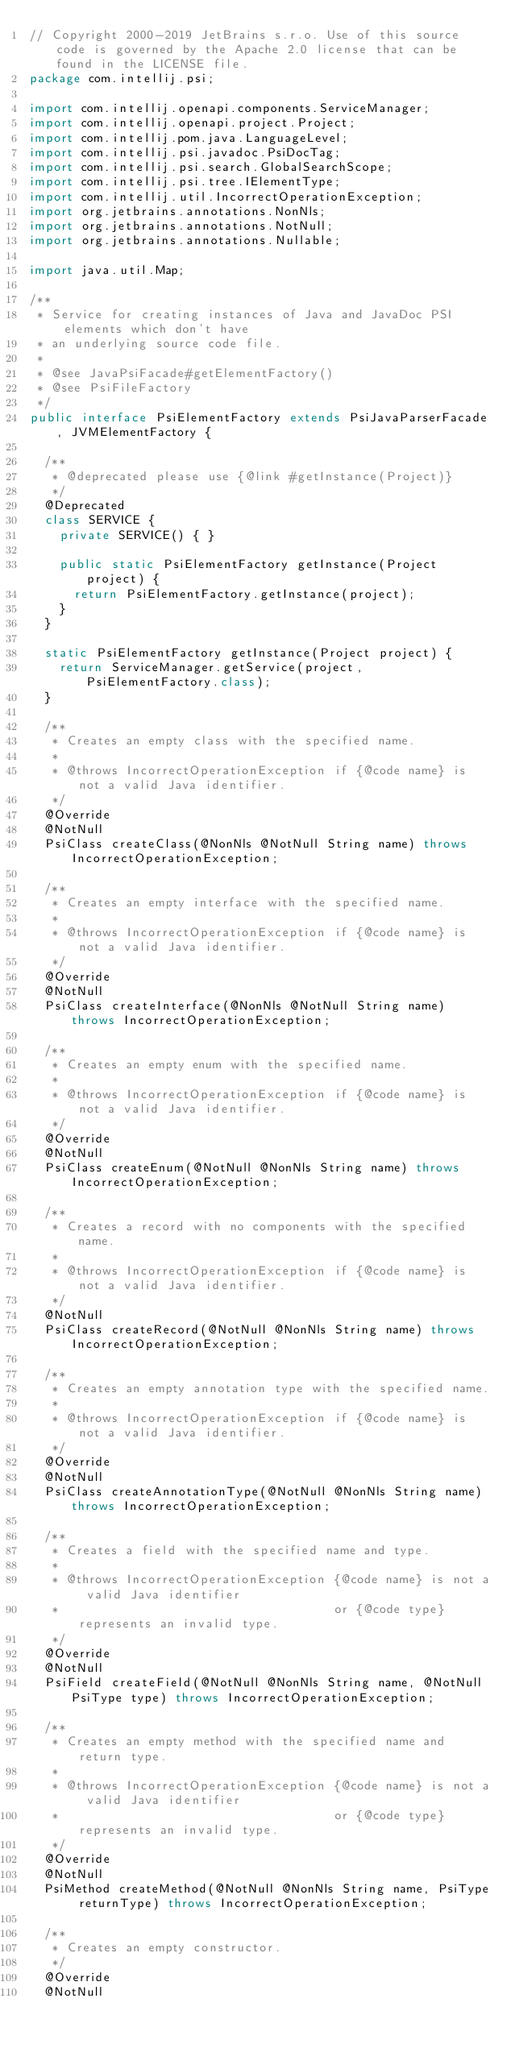Convert code to text. <code><loc_0><loc_0><loc_500><loc_500><_Java_>// Copyright 2000-2019 JetBrains s.r.o. Use of this source code is governed by the Apache 2.0 license that can be found in the LICENSE file.
package com.intellij.psi;

import com.intellij.openapi.components.ServiceManager;
import com.intellij.openapi.project.Project;
import com.intellij.pom.java.LanguageLevel;
import com.intellij.psi.javadoc.PsiDocTag;
import com.intellij.psi.search.GlobalSearchScope;
import com.intellij.psi.tree.IElementType;
import com.intellij.util.IncorrectOperationException;
import org.jetbrains.annotations.NonNls;
import org.jetbrains.annotations.NotNull;
import org.jetbrains.annotations.Nullable;

import java.util.Map;

/**
 * Service for creating instances of Java and JavaDoc PSI elements which don't have
 * an underlying source code file.
 *
 * @see JavaPsiFacade#getElementFactory()
 * @see PsiFileFactory
 */
public interface PsiElementFactory extends PsiJavaParserFacade, JVMElementFactory {

  /**
   * @deprecated please use {@link #getInstance(Project)}
   */
  @Deprecated
  class SERVICE {
    private SERVICE() { }

    public static PsiElementFactory getInstance(Project project) {
      return PsiElementFactory.getInstance(project);
    }
  }

  static PsiElementFactory getInstance(Project project) {
    return ServiceManager.getService(project, PsiElementFactory.class);
  }

  /**
   * Creates an empty class with the specified name.
   *
   * @throws IncorrectOperationException if {@code name} is not a valid Java identifier.
   */
  @Override
  @NotNull
  PsiClass createClass(@NonNls @NotNull String name) throws IncorrectOperationException;

  /**
   * Creates an empty interface with the specified name.
   *
   * @throws IncorrectOperationException if {@code name} is not a valid Java identifier.
   */
  @Override
  @NotNull
  PsiClass createInterface(@NonNls @NotNull String name) throws IncorrectOperationException;

  /**
   * Creates an empty enum with the specified name.
   *
   * @throws IncorrectOperationException if {@code name} is not a valid Java identifier.
   */
  @Override
  @NotNull
  PsiClass createEnum(@NotNull @NonNls String name) throws IncorrectOperationException;

  /**
   * Creates a record with no components with the specified name.
   *
   * @throws IncorrectOperationException if {@code name} is not a valid Java identifier.
   */
  @NotNull
  PsiClass createRecord(@NotNull @NonNls String name) throws IncorrectOperationException;

  /**
   * Creates an empty annotation type with the specified name.
   *
   * @throws IncorrectOperationException if {@code name} is not a valid Java identifier.
   */
  @Override
  @NotNull
  PsiClass createAnnotationType(@NotNull @NonNls String name) throws IncorrectOperationException;

  /**
   * Creates a field with the specified name and type.
   *
   * @throws IncorrectOperationException {@code name} is not a valid Java identifier
   *                                     or {@code type} represents an invalid type.
   */
  @Override
  @NotNull
  PsiField createField(@NotNull @NonNls String name, @NotNull PsiType type) throws IncorrectOperationException;

  /**
   * Creates an empty method with the specified name and return type.
   *
   * @throws IncorrectOperationException {@code name} is not a valid Java identifier
   *                                     or {@code type} represents an invalid type.
   */
  @Override
  @NotNull
  PsiMethod createMethod(@NotNull @NonNls String name, PsiType returnType) throws IncorrectOperationException;

  /**
   * Creates an empty constructor.
   */
  @Override
  @NotNull</code> 